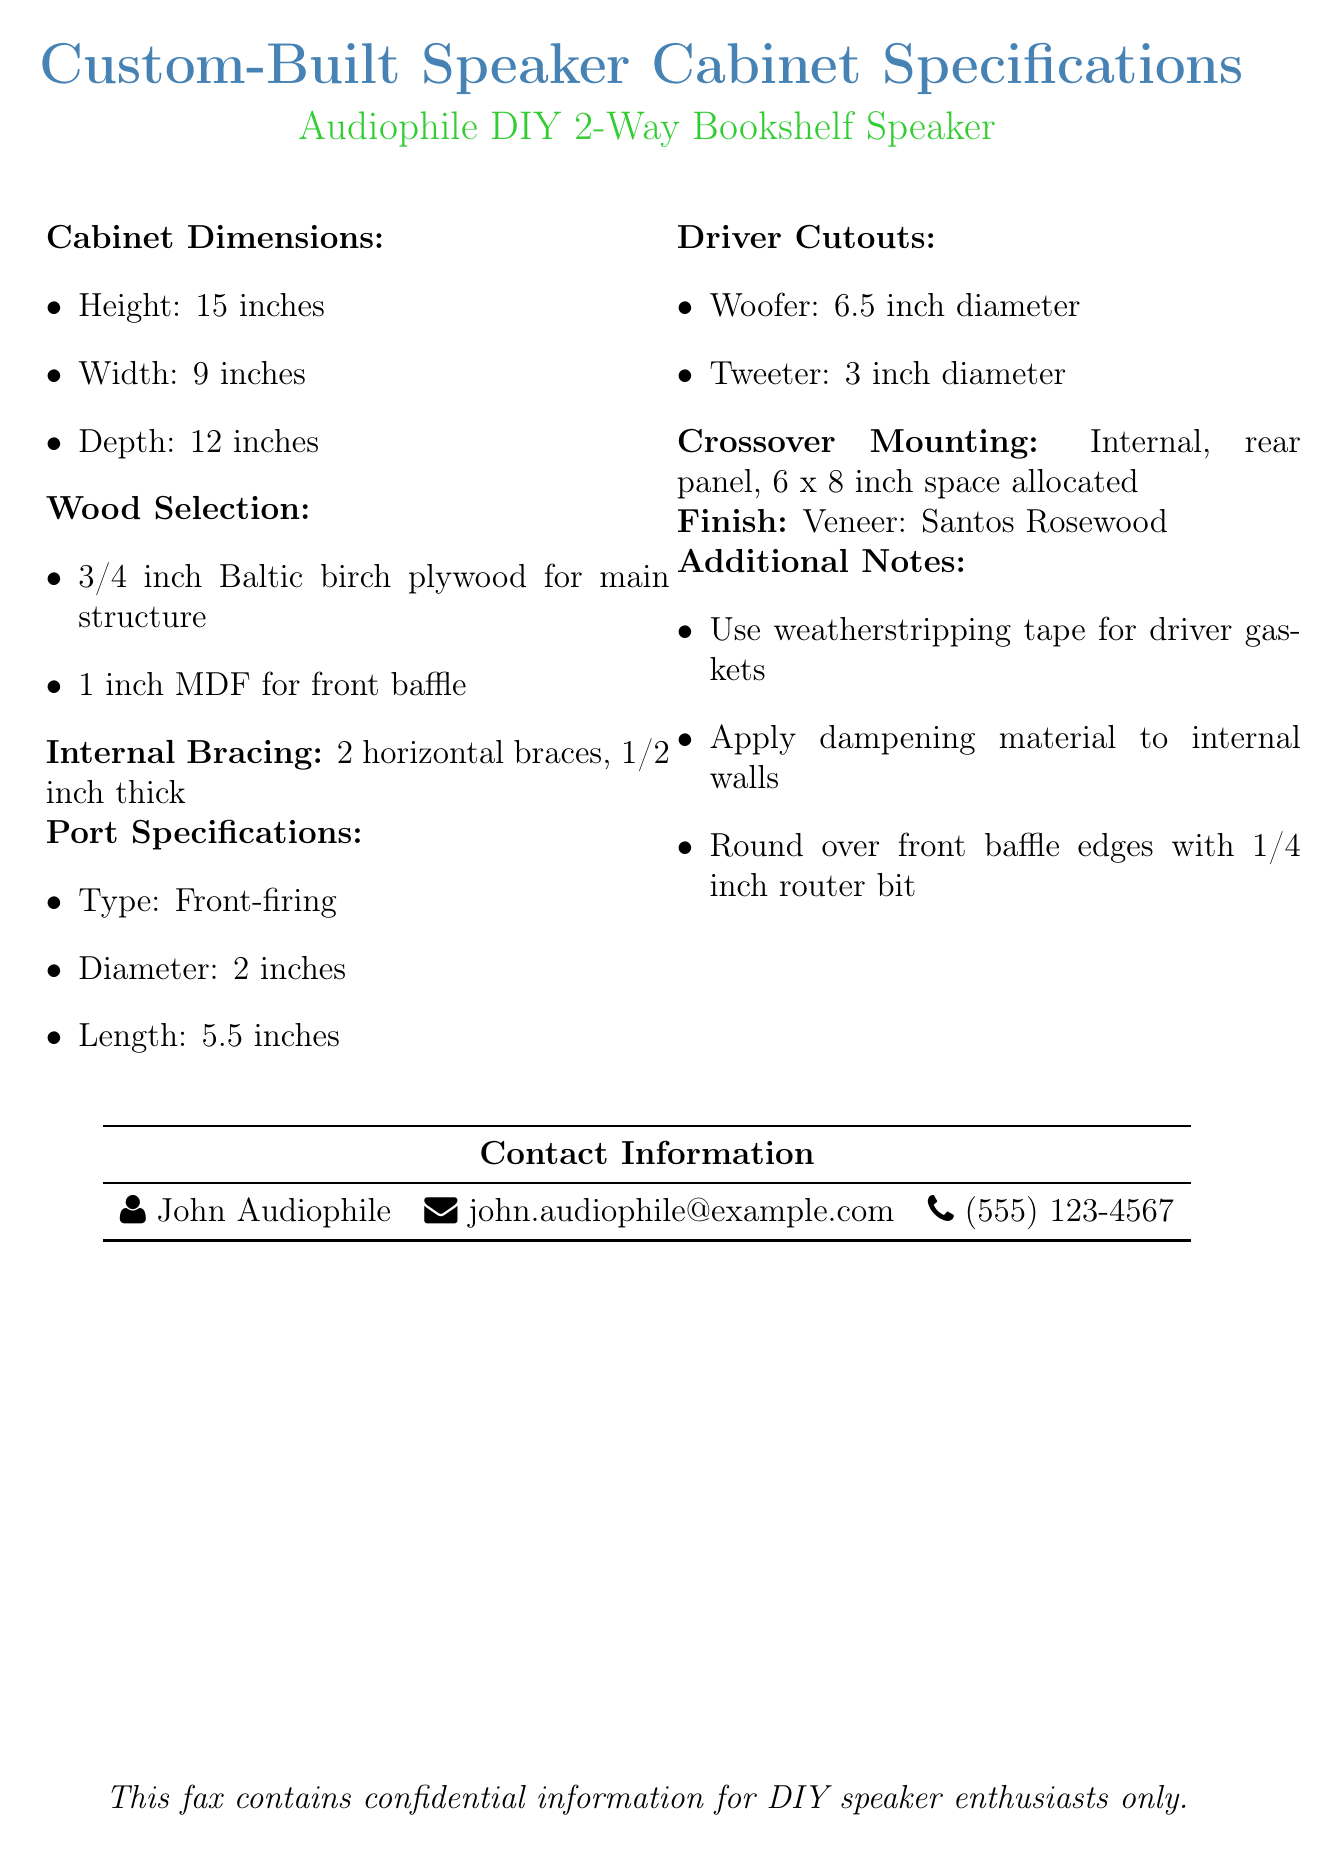What are the dimensions of the cabinet? The cabinet dimensions are provided in three measurements: height, width, and depth, which are 15 inches, 9 inches, and 12 inches respectively.
Answer: Height: 15 inches, Width: 9 inches, Depth: 12 inches What type of wood is used for the main structure? The wood selection specifies that 3/4 inch Baltic birch plywood is used for the main structure of the cabinet.
Answer: 3/4 inch Baltic birch plywood What is the diameter of the woofer cutout? The driver cutouts indicate that the diameter of the woofer cutout is 6.5 inches.
Answer: 6.5 inch diameter How many internal braces are included? The document specifies that there are 2 horizontal braces within the cabinet structure.
Answer: 2 horizontal braces What is the finish material for the cabinet? The finish section lists Santos Rosewood as the veneer used for the cabinet.
Answer: Santos Rosewood How thick is the front baffle? The wood selection states that the front baffle is made from 1 inch MDF.
Answer: 1 inch MDF What is allocated for crossover mounting? The crossover mounting section specifies a designated space of 6 by 8 inches on the internal rear panel.
Answer: 6 x 8 inch space What additional material is suggested for internal walls? The additional notes mention that a dampening material should be applied to the internal walls of the cabinet.
Answer: Dampening material Who is the contact person for this document? The contact information section identifies John Audiophile as the contact person for inquiries related to the specifications.
Answer: John Audiophile 